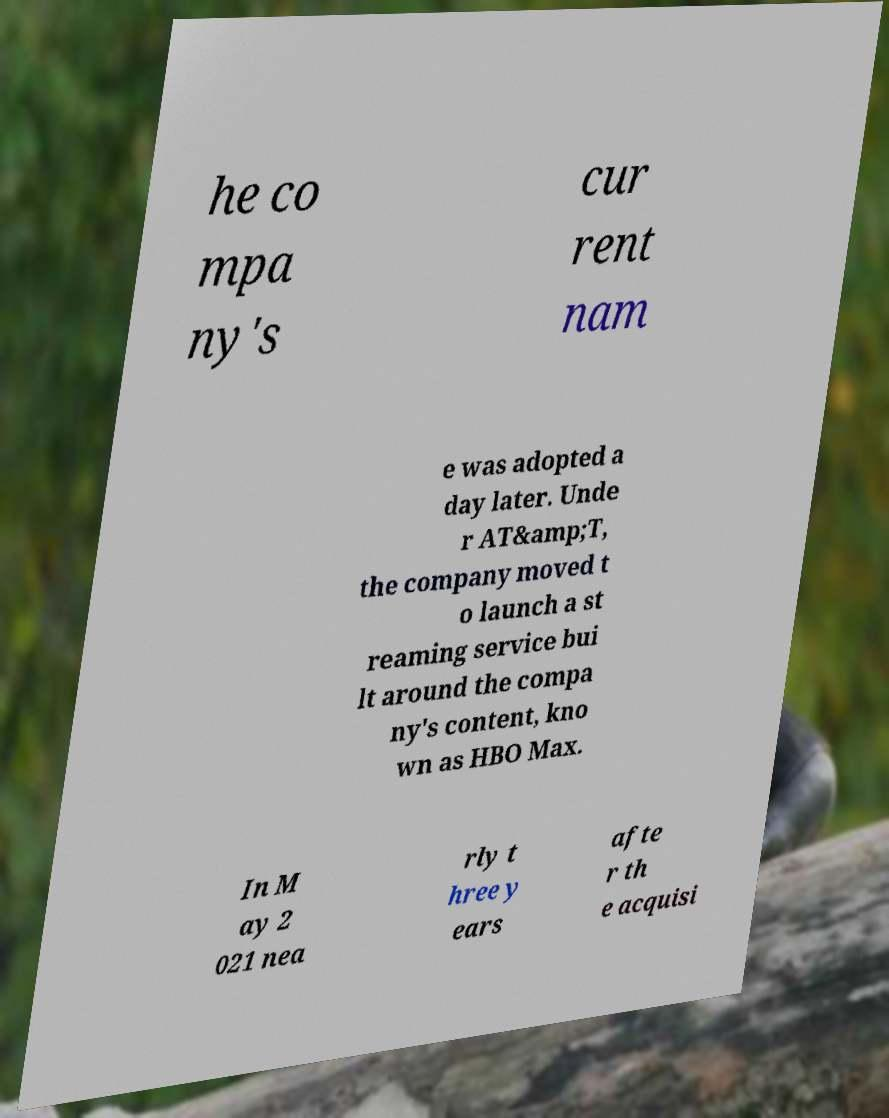What messages or text are displayed in this image? I need them in a readable, typed format. he co mpa ny's cur rent nam e was adopted a day later. Unde r AT&amp;T, the company moved t o launch a st reaming service bui lt around the compa ny's content, kno wn as HBO Max. In M ay 2 021 nea rly t hree y ears afte r th e acquisi 